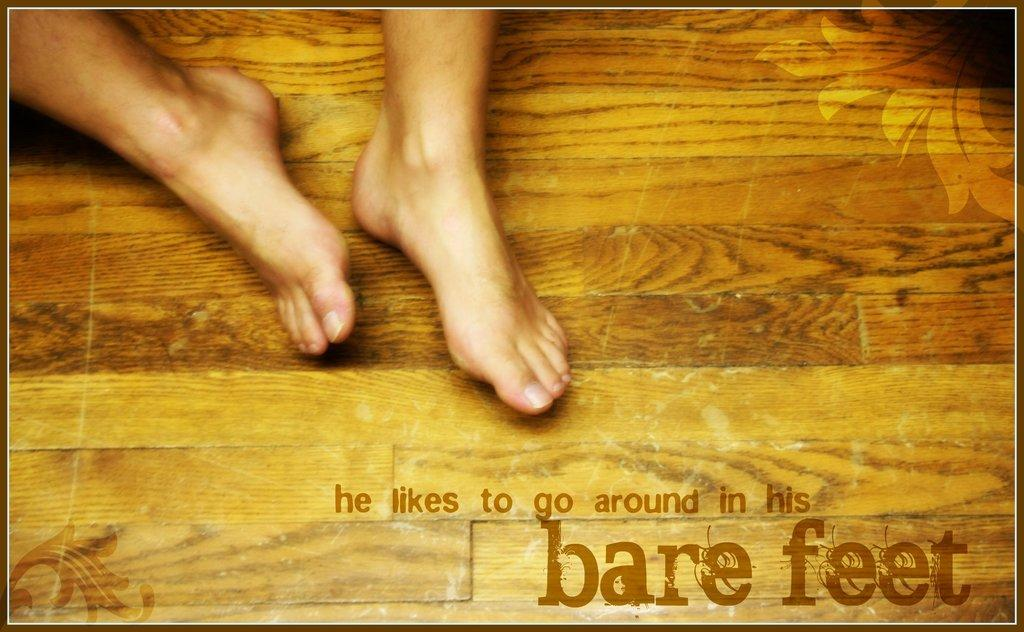Provide a one-sentence caption for the provided image. Bare feet can be seen on a wood floor, with a statement that he likes to go around with bare feet. 